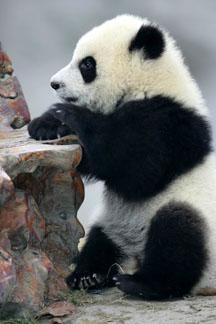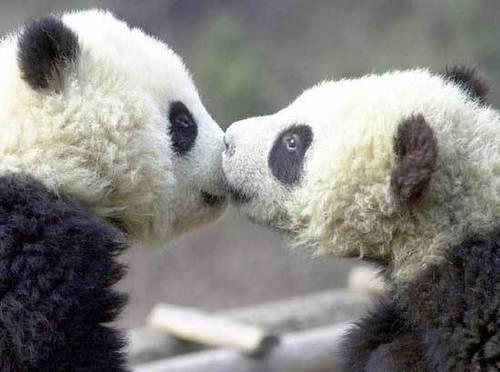The first image is the image on the left, the second image is the image on the right. For the images shown, is this caption "The left and right image contains the same number of pandas." true? Answer yes or no. No. The first image is the image on the left, the second image is the image on the right. Evaluate the accuracy of this statement regarding the images: "The right image shows a baby panda with a pink nose and fuzzy fur, posed on a blanket with the toes of two limbs turning inward.". Is it true? Answer yes or no. No. 